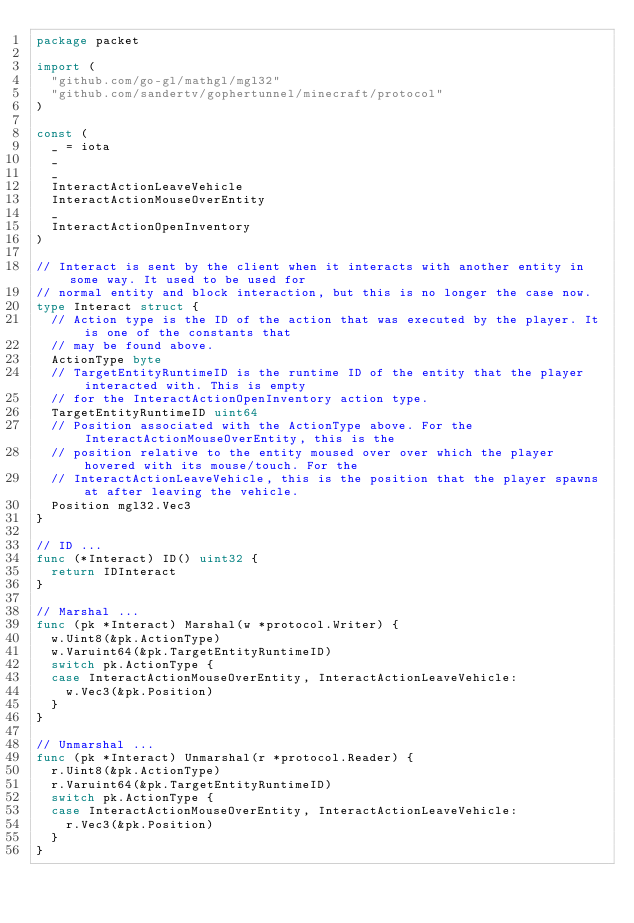<code> <loc_0><loc_0><loc_500><loc_500><_Go_>package packet

import (
	"github.com/go-gl/mathgl/mgl32"
	"github.com/sandertv/gophertunnel/minecraft/protocol"
)

const (
	_ = iota
	_
	_
	InteractActionLeaveVehicle
	InteractActionMouseOverEntity
	_
	InteractActionOpenInventory
)

// Interact is sent by the client when it interacts with another entity in some way. It used to be used for
// normal entity and block interaction, but this is no longer the case now.
type Interact struct {
	// Action type is the ID of the action that was executed by the player. It is one of the constants that
	// may be found above.
	ActionType byte
	// TargetEntityRuntimeID is the runtime ID of the entity that the player interacted with. This is empty
	// for the InteractActionOpenInventory action type.
	TargetEntityRuntimeID uint64
	// Position associated with the ActionType above. For the InteractActionMouseOverEntity, this is the
	// position relative to the entity moused over over which the player hovered with its mouse/touch. For the
	// InteractActionLeaveVehicle, this is the position that the player spawns at after leaving the vehicle.
	Position mgl32.Vec3
}

// ID ...
func (*Interact) ID() uint32 {
	return IDInteract
}

// Marshal ...
func (pk *Interact) Marshal(w *protocol.Writer) {
	w.Uint8(&pk.ActionType)
	w.Varuint64(&pk.TargetEntityRuntimeID)
	switch pk.ActionType {
	case InteractActionMouseOverEntity, InteractActionLeaveVehicle:
		w.Vec3(&pk.Position)
	}
}

// Unmarshal ...
func (pk *Interact) Unmarshal(r *protocol.Reader) {
	r.Uint8(&pk.ActionType)
	r.Varuint64(&pk.TargetEntityRuntimeID)
	switch pk.ActionType {
	case InteractActionMouseOverEntity, InteractActionLeaveVehicle:
		r.Vec3(&pk.Position)
	}
}
</code> 